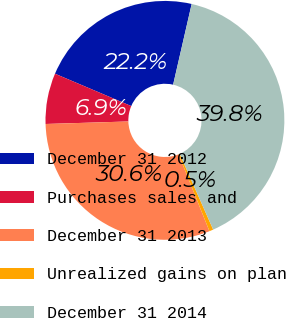Convert chart to OTSL. <chart><loc_0><loc_0><loc_500><loc_500><pie_chart><fcel>December 31 2012<fcel>Purchases sales and<fcel>December 31 2013<fcel>Unrealized gains on plan<fcel>December 31 2014<nl><fcel>22.21%<fcel>6.87%<fcel>30.6%<fcel>0.54%<fcel>39.79%<nl></chart> 